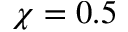<formula> <loc_0><loc_0><loc_500><loc_500>\chi = 0 . 5</formula> 